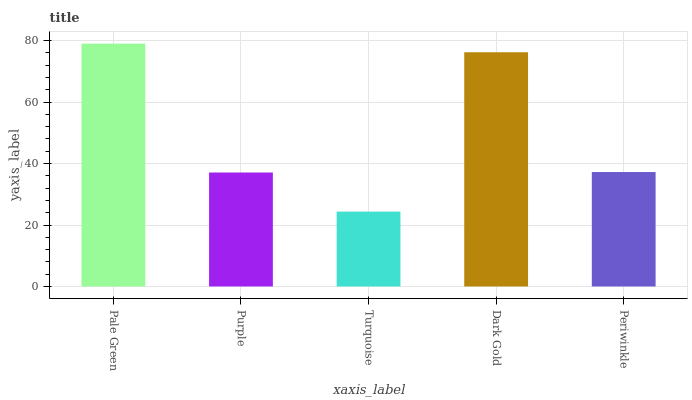Is Purple the minimum?
Answer yes or no. No. Is Purple the maximum?
Answer yes or no. No. Is Pale Green greater than Purple?
Answer yes or no. Yes. Is Purple less than Pale Green?
Answer yes or no. Yes. Is Purple greater than Pale Green?
Answer yes or no. No. Is Pale Green less than Purple?
Answer yes or no. No. Is Periwinkle the high median?
Answer yes or no. Yes. Is Periwinkle the low median?
Answer yes or no. Yes. Is Turquoise the high median?
Answer yes or no. No. Is Turquoise the low median?
Answer yes or no. No. 